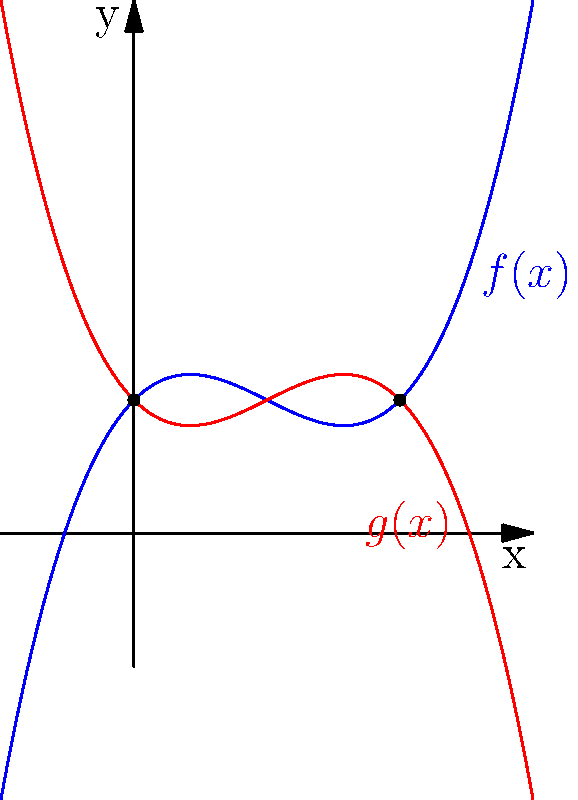As a former hockey player, you're familiar with the importance of equipment design. Now, consider a canoe paddle blade's shape described by two polynomial functions: $f(x) = 0.5x^3 - 1.5x^2 + x + 1$ (blue curve) and $g(x) = -0.5x^3 + 1.5x^2 - x + 1$ (red curve). What is the area enclosed between these two curves? To find the area between the two curves, we need to:

1. Find the points of intersection:
   Set $f(x) = g(x)$:
   $0.5x^3 - 1.5x^2 + x + 1 = -0.5x^3 + 1.5x^2 - x + 1$
   Simplifying: $x^3 - 3x^2 + 2x = 0$
   Factoring: $x(x^2 - 3x + 2) = 0$
   $x(x - 1)(x - 2) = 0$
   So, $x = 0$ or $x = 1$ or $x = 2$

2. Set up the integral:
   Area = $\int_0^2 [f(x) - g(x)] dx$

3. Calculate the integral:
   $\int_0^2 [(0.5x^3 - 1.5x^2 + x + 1) - (-0.5x^3 + 1.5x^2 - x + 1)] dx$
   $= \int_0^2 (x^3 - 3x^2 + 2x) dx$
   $= [\frac{1}{4}x^4 - x^3 + x^2]_0^2$
   $= (\frac{16}{4} - 8 + 4) - (0 - 0 + 0)$
   $= 4 - 8 + 4 = 0$

Therefore, the area enclosed between the two curves is 0 square units.
Answer: 0 square units 